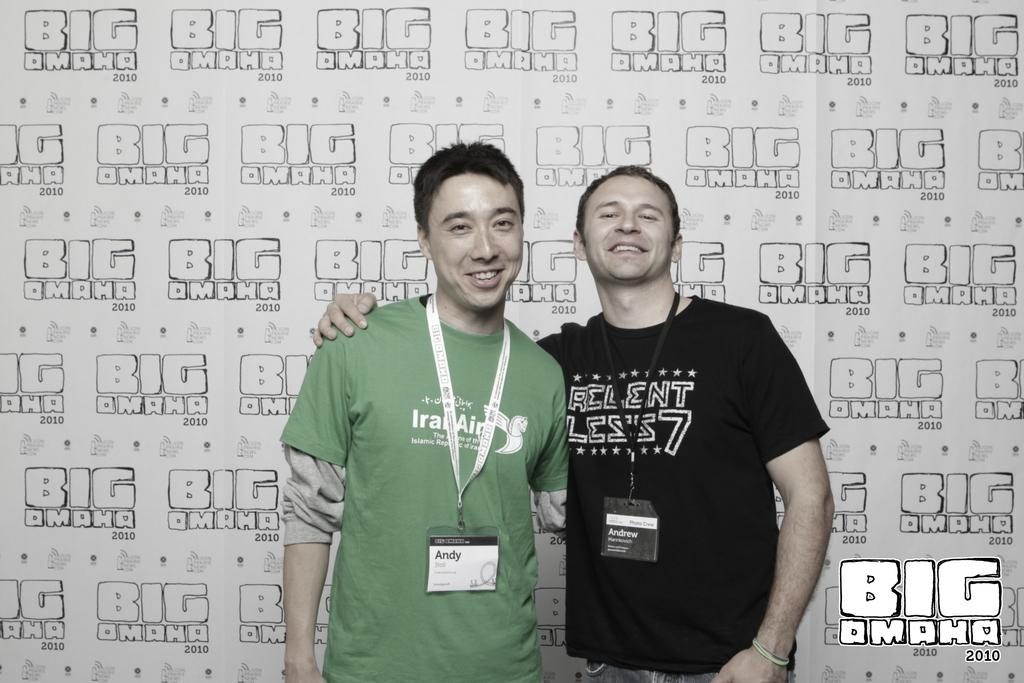How many people are in the image? There are two persons standing in the image. What is visible behind the persons? There is a banner with text behind the persons. What are the persons wearing that indicates their affiliation or identity? The persons are wearing identity cards. Where can some text be found in the image? There is some text in the right bottom of the image. Can you tell me the color of the frog sitting on the governor's shoulder in the image? There is no frog or governor present in the image. What angle is the image taken from? The angle from which the image is taken is not mentioned in the provided facts. 